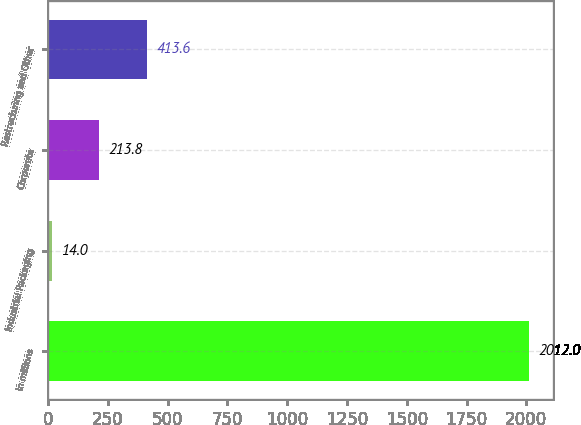<chart> <loc_0><loc_0><loc_500><loc_500><bar_chart><fcel>In millions<fcel>Industrial Packaging<fcel>Corporate<fcel>Restructuring and Other<nl><fcel>2012<fcel>14<fcel>213.8<fcel>413.6<nl></chart> 